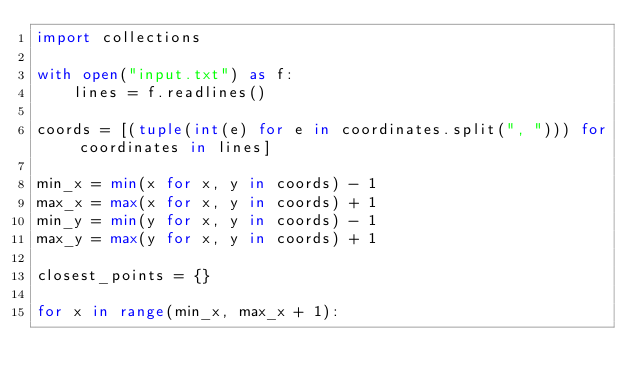Convert code to text. <code><loc_0><loc_0><loc_500><loc_500><_Python_>import collections

with open("input.txt") as f:
    lines = f.readlines()

coords = [(tuple(int(e) for e in coordinates.split(", "))) for coordinates in lines]

min_x = min(x for x, y in coords) - 1
max_x = max(x for x, y in coords) + 1
min_y = min(y for x, y in coords) - 1
max_y = max(y for x, y in coords) + 1

closest_points = {}

for x in range(min_x, max_x + 1):</code> 